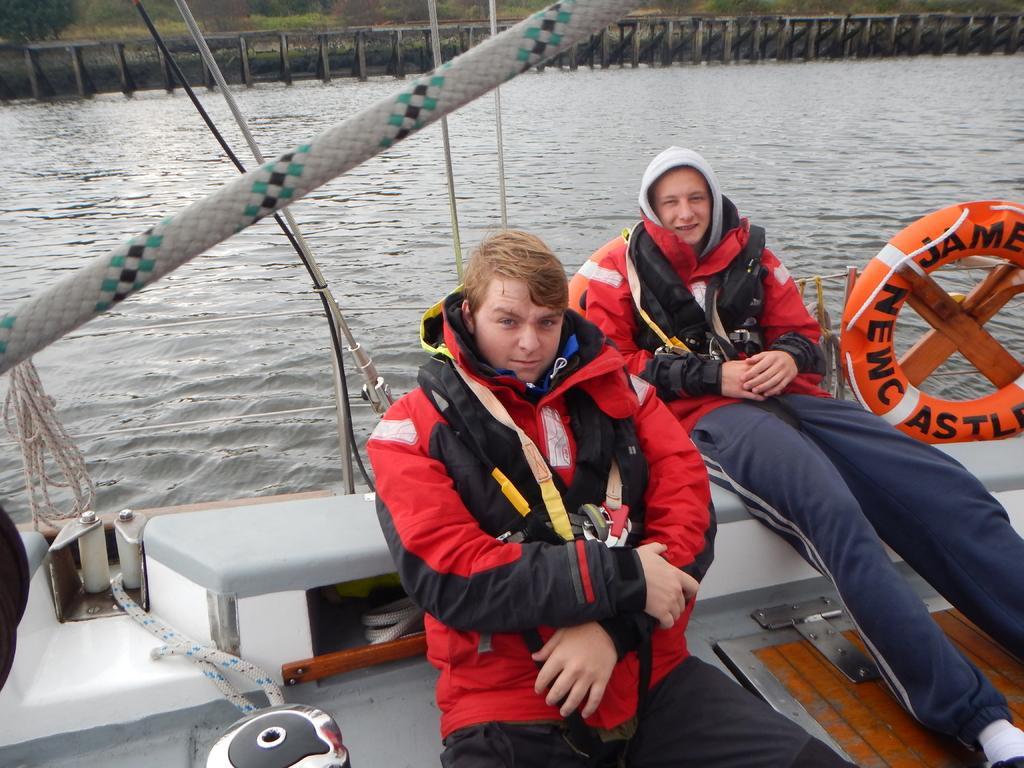How would you summarize this image in a sentence or two? In the image there are two persons in red life jackets sitting on boat in the river and in the back it seems to be a bridge. 